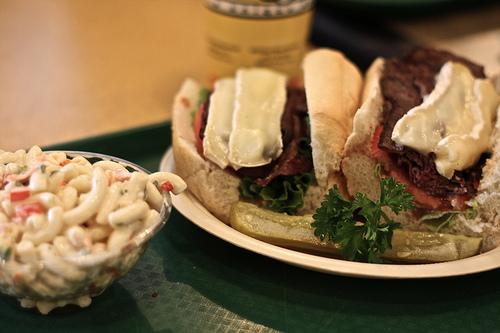Provide a concise description of the most prominent elements of the image. Two roast beef sandwiches, a bowl of macaroni salad, and a pickle slice with parsley on a plate surrounded by a green tray and wooden table. Mention what food is being served and on what type of surface. A roast beef sandwich, macaroni salad in a bowl, pickle with parsley and tomatoes, served on a green tray placed on a wooden table. Explain the visual appearance of the main food items and how they are arranged. The image has two sandwiches with bread, cheese, and roast beef, arranged around a bowl of macaroni salad, tomatoes, and a slice of pickle with parsley, placed on a green tray. Mention the main components of the image focusing on the colors and textures present. Roast beef sandwiches, a creamy white macaroni salad in a bowl, vibrant green parsley on a pickle, and red sliced tomatoes on a green tray with a wooden table background. Give a brief summary of the meal presented in the image. Lunch consists of sandwiches with roast beef and lettuce, macaroni salad, kosher pickle, and sliced tomatoes on a green placemat. Describe the image as if you were presenting it on a food blog. Today's featured lunch is a delightful mix of flavors – mouthwatering roast beef sandwiches, a flavorful bowl of macaroni salad, crisp tomatoes, and a zesty pickle slice topped with fresh parsley, all served on a charming green tray atop a rustic wooden table. Describe the food and table setting in a casual, informal way. Yummy-looking roast beef sandwiches, a bowl of creamy macaroni salad, tomatoes, and a big pickle, all set up on a cool green tray and wooden table. Give a poetic description of the image focusing on the key elements of the scene. Amidst a meal shared on wooden shores, lies a tempting symphony of flavors: the comforting embrace of a roast beef sandwich, the creamy whispers of macaroni salad, a pickle adorned with a green crown of parsley, and sliced tomatoes adding a burst of hue to the treasured green tray. Provide a quick overview of the food items and tableware visible in the image. Roast beef sandwiches on white bread, a bowl of macaroni salad, a slice of pickle with parsley, and red juicy tomatoes are served on a green tray set on a wooden table. Imagine you are describing the image to someone who loves food. Make it appetizing and appealing. A delectable lunch spread featuring juicy roast beef sandwiches, a creamy and rich macaroni salad, tangy pickle garnished with fragrant parsley, and fresh, juicy tomato slices on a vibrant green tray. 